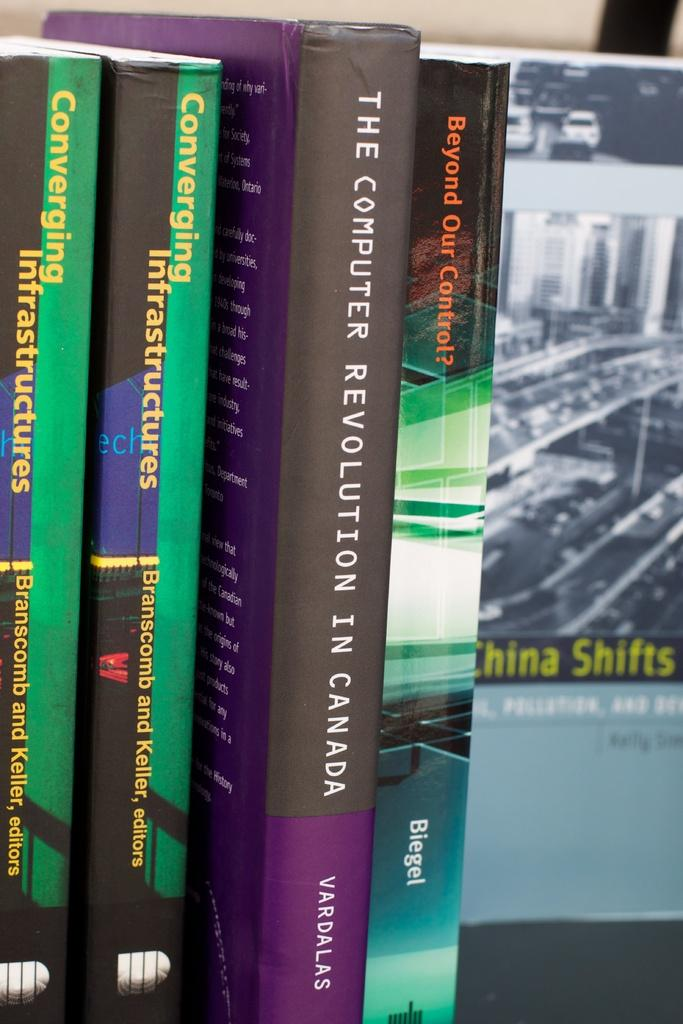<image>
Write a terse but informative summary of the picture. A purple book titled The computer revolution in Canada 